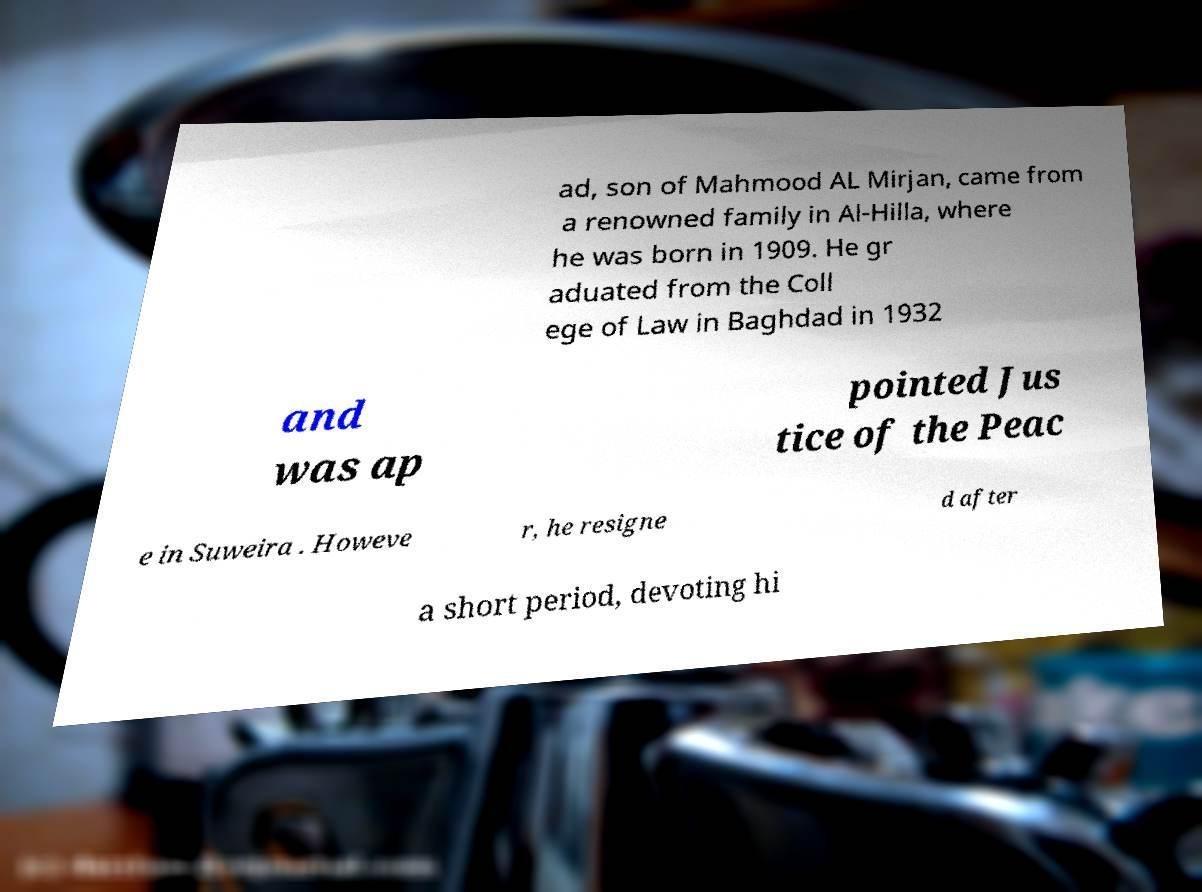For documentation purposes, I need the text within this image transcribed. Could you provide that? ad, son of Mahmood AL Mirjan, came from a renowned family in Al-Hilla, where he was born in 1909. He gr aduated from the Coll ege of Law in Baghdad in 1932 and was ap pointed Jus tice of the Peac e in Suweira . Howeve r, he resigne d after a short period, devoting hi 